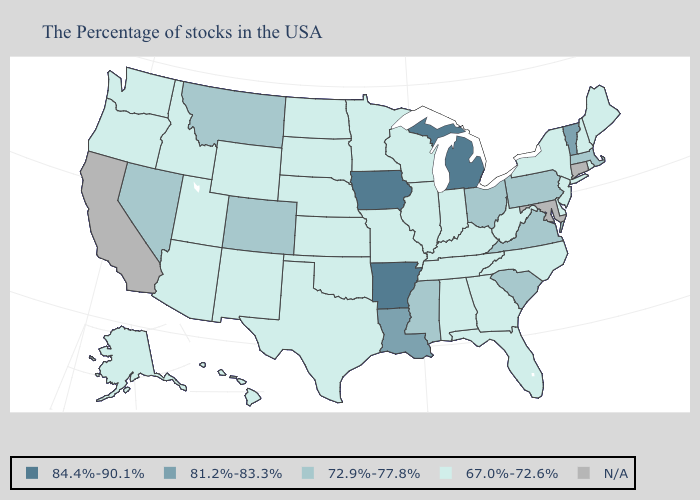Name the states that have a value in the range N/A?
Give a very brief answer. Connecticut, Maryland, California. Among the states that border North Carolina , does Tennessee have the highest value?
Answer briefly. No. Name the states that have a value in the range N/A?
Be succinct. Connecticut, Maryland, California. Name the states that have a value in the range N/A?
Keep it brief. Connecticut, Maryland, California. What is the highest value in states that border Oregon?
Be succinct. 72.9%-77.8%. Does the first symbol in the legend represent the smallest category?
Give a very brief answer. No. What is the value of South Dakota?
Concise answer only. 67.0%-72.6%. What is the value of Maryland?
Give a very brief answer. N/A. Which states have the lowest value in the MidWest?
Write a very short answer. Indiana, Wisconsin, Illinois, Missouri, Minnesota, Kansas, Nebraska, South Dakota, North Dakota. Is the legend a continuous bar?
Quick response, please. No. Which states hav the highest value in the South?
Be succinct. Arkansas. Which states hav the highest value in the MidWest?
Answer briefly. Michigan, Iowa. What is the highest value in the USA?
Give a very brief answer. 84.4%-90.1%. What is the value of Idaho?
Keep it brief. 67.0%-72.6%. 